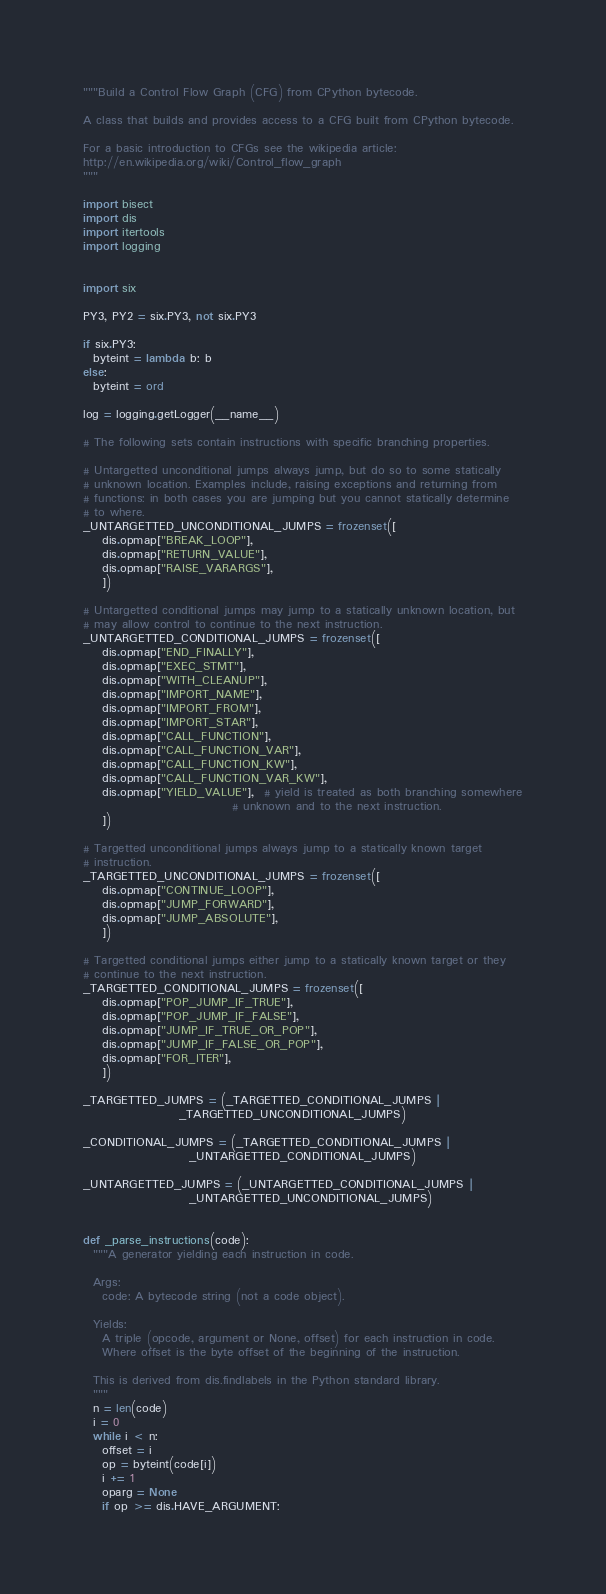Convert code to text. <code><loc_0><loc_0><loc_500><loc_500><_Python_>"""Build a Control Flow Graph (CFG) from CPython bytecode.

A class that builds and provides access to a CFG built from CPython bytecode.

For a basic introduction to CFGs see the wikipedia article:
http://en.wikipedia.org/wiki/Control_flow_graph
"""

import bisect
import dis
import itertools
import logging


import six

PY3, PY2 = six.PY3, not six.PY3

if six.PY3:
  byteint = lambda b: b
else:
  byteint = ord

log = logging.getLogger(__name__)

# The following sets contain instructions with specific branching properties.

# Untargetted unconditional jumps always jump, but do so to some statically
# unknown location. Examples include, raising exceptions and returning from
# functions: in both cases you are jumping but you cannot statically determine
# to where.
_UNTARGETTED_UNCONDITIONAL_JUMPS = frozenset([
    dis.opmap["BREAK_LOOP"],
    dis.opmap["RETURN_VALUE"],
    dis.opmap["RAISE_VARARGS"],
    ])

# Untargetted conditional jumps may jump to a statically unknown location, but
# may allow control to continue to the next instruction.
_UNTARGETTED_CONDITIONAL_JUMPS = frozenset([
    dis.opmap["END_FINALLY"],
    dis.opmap["EXEC_STMT"],
    dis.opmap["WITH_CLEANUP"],
    dis.opmap["IMPORT_NAME"],
    dis.opmap["IMPORT_FROM"],
    dis.opmap["IMPORT_STAR"],
    dis.opmap["CALL_FUNCTION"],
    dis.opmap["CALL_FUNCTION_VAR"],
    dis.opmap["CALL_FUNCTION_KW"],
    dis.opmap["CALL_FUNCTION_VAR_KW"],
    dis.opmap["YIELD_VALUE"],  # yield is treated as both branching somewhere
                               # unknown and to the next instruction.
    ])

# Targetted unconditional jumps always jump to a statically known target
# instruction.
_TARGETTED_UNCONDITIONAL_JUMPS = frozenset([
    dis.opmap["CONTINUE_LOOP"],
    dis.opmap["JUMP_FORWARD"],
    dis.opmap["JUMP_ABSOLUTE"],
    ])

# Targetted conditional jumps either jump to a statically known target or they
# continue to the next instruction.
_TARGETTED_CONDITIONAL_JUMPS = frozenset([
    dis.opmap["POP_JUMP_IF_TRUE"],
    dis.opmap["POP_JUMP_IF_FALSE"],
    dis.opmap["JUMP_IF_TRUE_OR_POP"],
    dis.opmap["JUMP_IF_FALSE_OR_POP"],
    dis.opmap["FOR_ITER"],
    ])

_TARGETTED_JUMPS = (_TARGETTED_CONDITIONAL_JUMPS |
                    _TARGETTED_UNCONDITIONAL_JUMPS)

_CONDITIONAL_JUMPS = (_TARGETTED_CONDITIONAL_JUMPS |
                      _UNTARGETTED_CONDITIONAL_JUMPS)

_UNTARGETTED_JUMPS = (_UNTARGETTED_CONDITIONAL_JUMPS |
                      _UNTARGETTED_UNCONDITIONAL_JUMPS)


def _parse_instructions(code):
  """A generator yielding each instruction in code.

  Args:
    code: A bytecode string (not a code object).

  Yields:
    A triple (opcode, argument or None, offset) for each instruction in code.
    Where offset is the byte offset of the beginning of the instruction.

  This is derived from dis.findlabels in the Python standard library.
  """
  n = len(code)
  i = 0
  while i < n:
    offset = i
    op = byteint(code[i])
    i += 1
    oparg = None
    if op >= dis.HAVE_ARGUMENT:</code> 